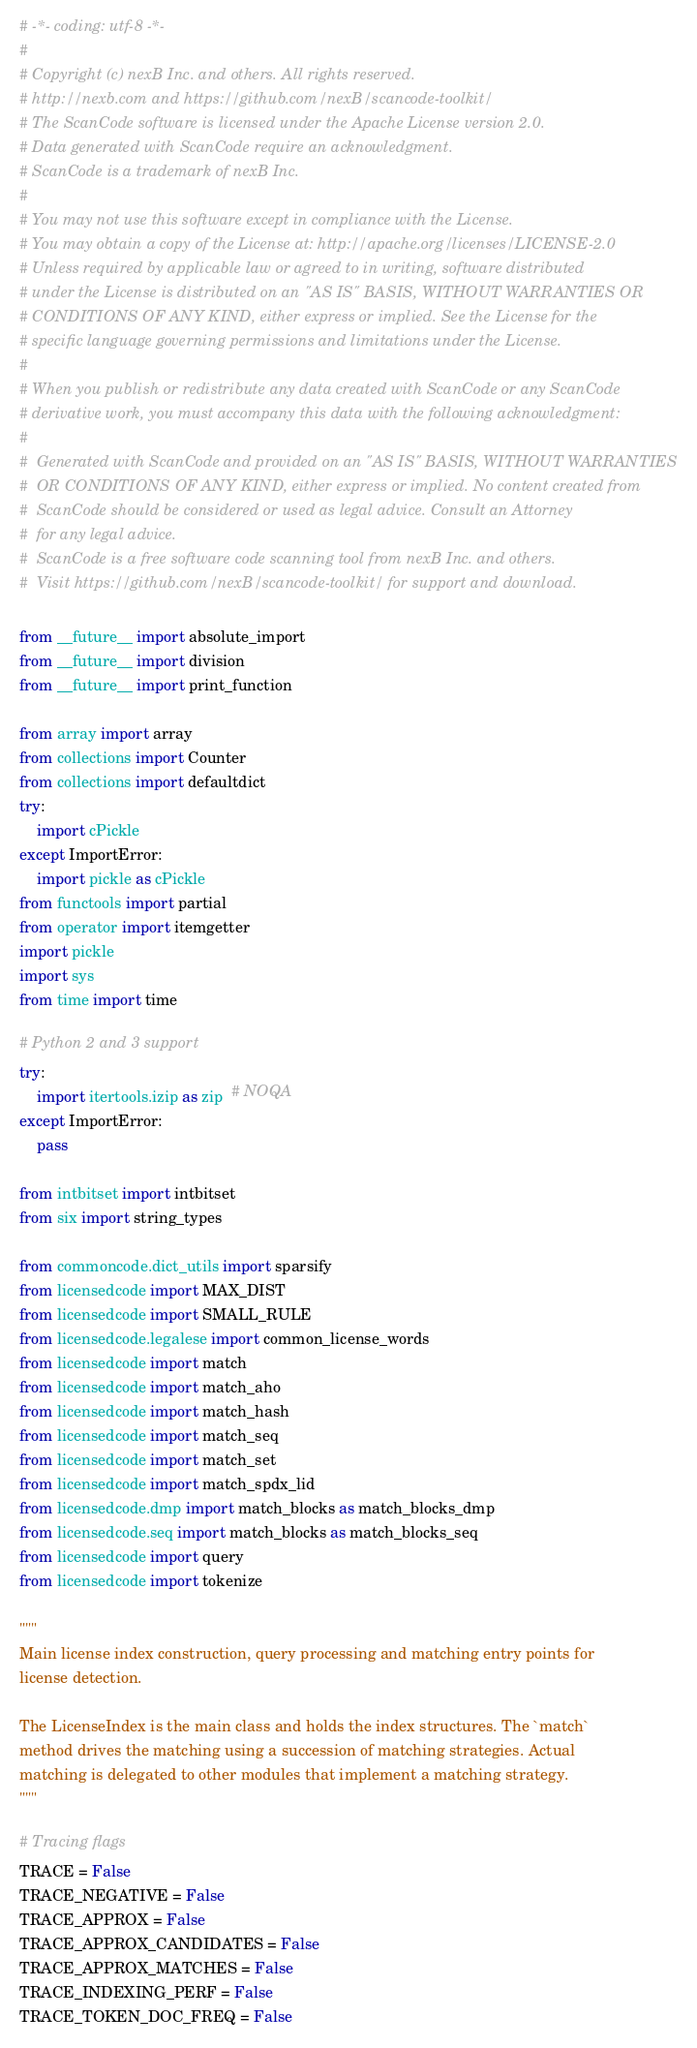<code> <loc_0><loc_0><loc_500><loc_500><_Python_># -*- coding: utf-8 -*-
#
# Copyright (c) nexB Inc. and others. All rights reserved.
# http://nexb.com and https://github.com/nexB/scancode-toolkit/
# The ScanCode software is licensed under the Apache License version 2.0.
# Data generated with ScanCode require an acknowledgment.
# ScanCode is a trademark of nexB Inc.
#
# You may not use this software except in compliance with the License.
# You may obtain a copy of the License at: http://apache.org/licenses/LICENSE-2.0
# Unless required by applicable law or agreed to in writing, software distributed
# under the License is distributed on an "AS IS" BASIS, WITHOUT WARRANTIES OR
# CONDITIONS OF ANY KIND, either express or implied. See the License for the
# specific language governing permissions and limitations under the License.
#
# When you publish or redistribute any data created with ScanCode or any ScanCode
# derivative work, you must accompany this data with the following acknowledgment:
#
#  Generated with ScanCode and provided on an "AS IS" BASIS, WITHOUT WARRANTIES
#  OR CONDITIONS OF ANY KIND, either express or implied. No content created from
#  ScanCode should be considered or used as legal advice. Consult an Attorney
#  for any legal advice.
#  ScanCode is a free software code scanning tool from nexB Inc. and others.
#  Visit https://github.com/nexB/scancode-toolkit/ for support and download.

from __future__ import absolute_import
from __future__ import division
from __future__ import print_function

from array import array
from collections import Counter
from collections import defaultdict
try:
    import cPickle
except ImportError:
    import pickle as cPickle
from functools import partial
from operator import itemgetter
import pickle
import sys
from time import time

# Python 2 and 3 support
try:
    import itertools.izip as zip  # NOQA
except ImportError:
    pass

from intbitset import intbitset
from six import string_types

from commoncode.dict_utils import sparsify
from licensedcode import MAX_DIST
from licensedcode import SMALL_RULE
from licensedcode.legalese import common_license_words
from licensedcode import match
from licensedcode import match_aho
from licensedcode import match_hash
from licensedcode import match_seq
from licensedcode import match_set
from licensedcode import match_spdx_lid
from licensedcode.dmp import match_blocks as match_blocks_dmp
from licensedcode.seq import match_blocks as match_blocks_seq
from licensedcode import query
from licensedcode import tokenize

"""
Main license index construction, query processing and matching entry points for
license detection.

The LicenseIndex is the main class and holds the index structures. The `match`
method drives the matching using a succession of matching strategies. Actual
matching is delegated to other modules that implement a matching strategy.
"""

# Tracing flags
TRACE = False
TRACE_NEGATIVE = False
TRACE_APPROX = False
TRACE_APPROX_CANDIDATES = False
TRACE_APPROX_MATCHES = False
TRACE_INDEXING_PERF = False
TRACE_TOKEN_DOC_FREQ = False

</code> 